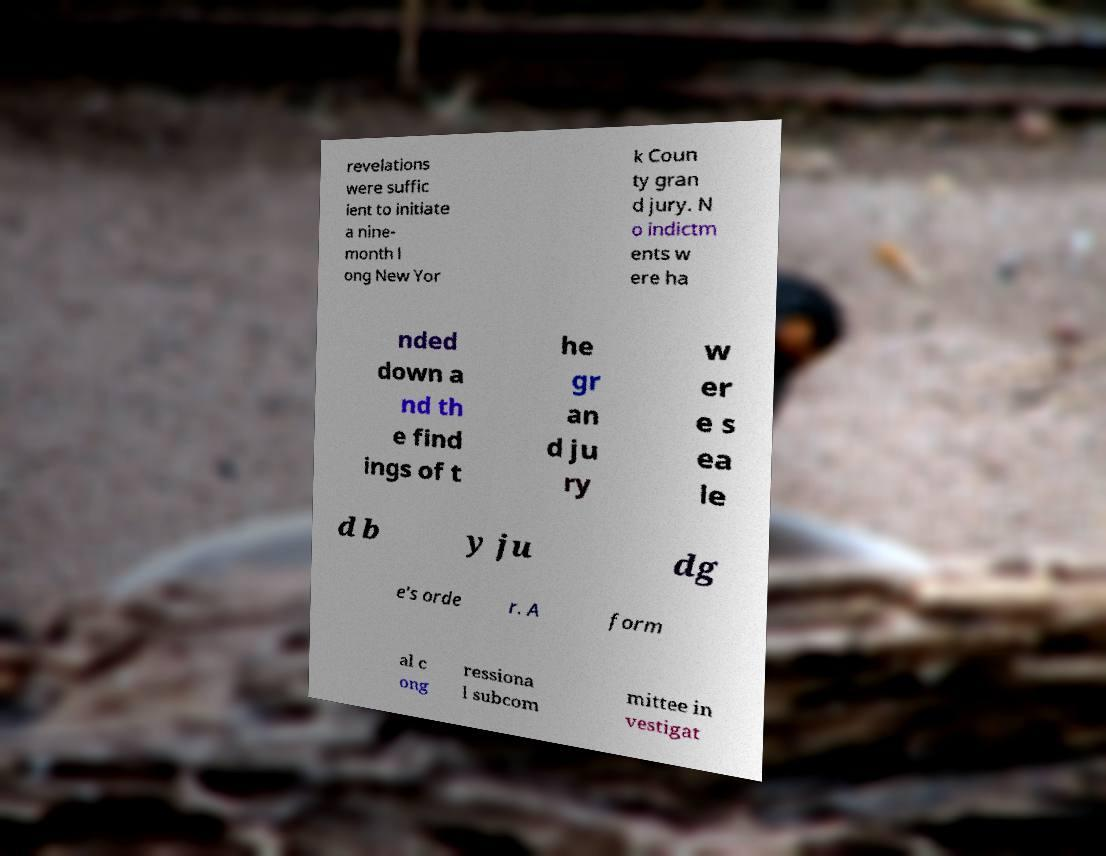There's text embedded in this image that I need extracted. Can you transcribe it verbatim? revelations were suffic ient to initiate a nine- month l ong New Yor k Coun ty gran d jury. N o indictm ents w ere ha nded down a nd th e find ings of t he gr an d ju ry w er e s ea le d b y ju dg e's orde r. A form al c ong ressiona l subcom mittee in vestigat 